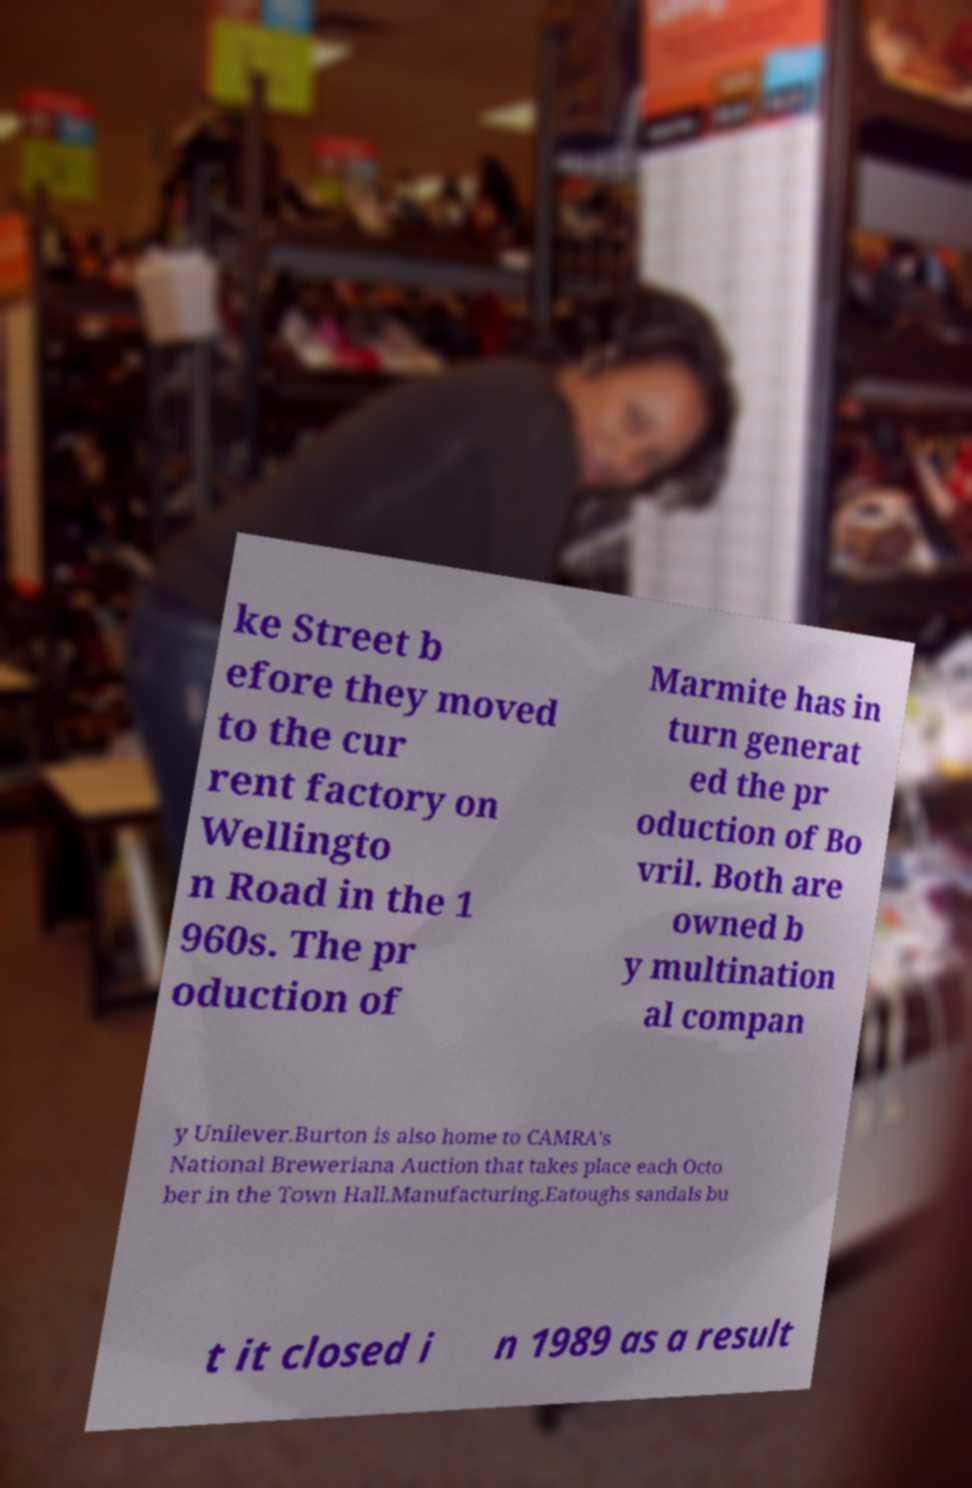I need the written content from this picture converted into text. Can you do that? ke Street b efore they moved to the cur rent factory on Wellingto n Road in the 1 960s. The pr oduction of Marmite has in turn generat ed the pr oduction of Bo vril. Both are owned b y multination al compan y Unilever.Burton is also home to CAMRA's National Breweriana Auction that takes place each Octo ber in the Town Hall.Manufacturing.Eatoughs sandals bu t it closed i n 1989 as a result 